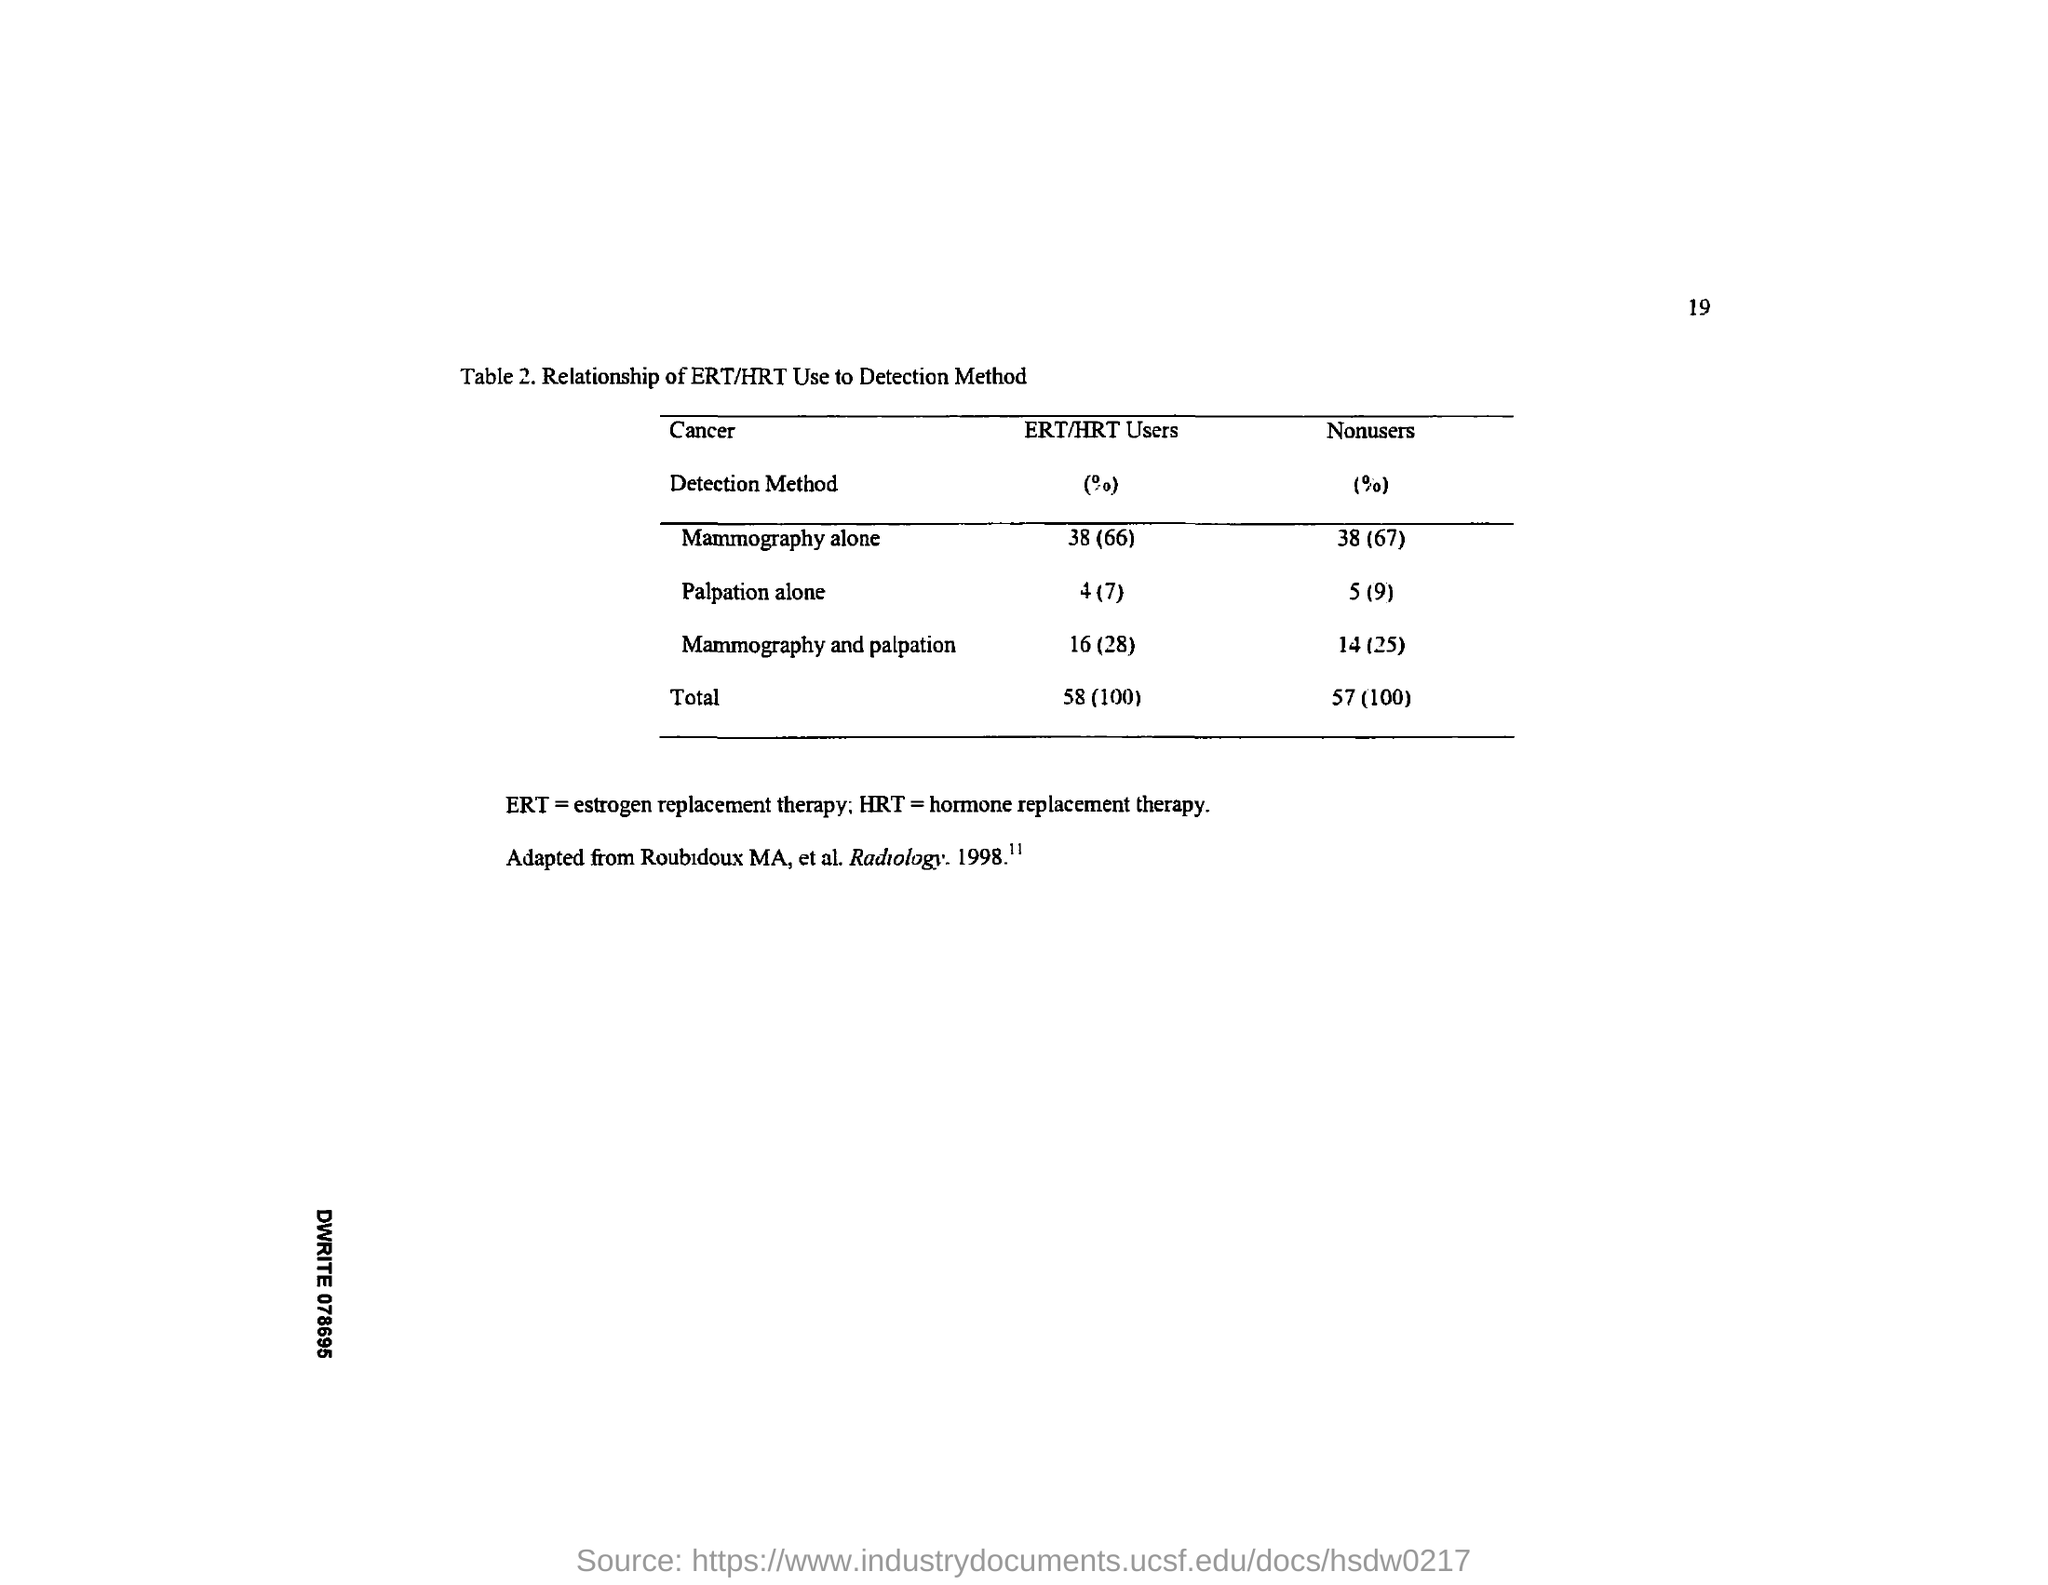Point out several critical features in this image. ERT stands for Estrogen Replacement Therapy. Hormone replacement therapy, commonly referred to as HRT, is a medical treatment that involves the use of hormones to replace those that are lacking in the body. 